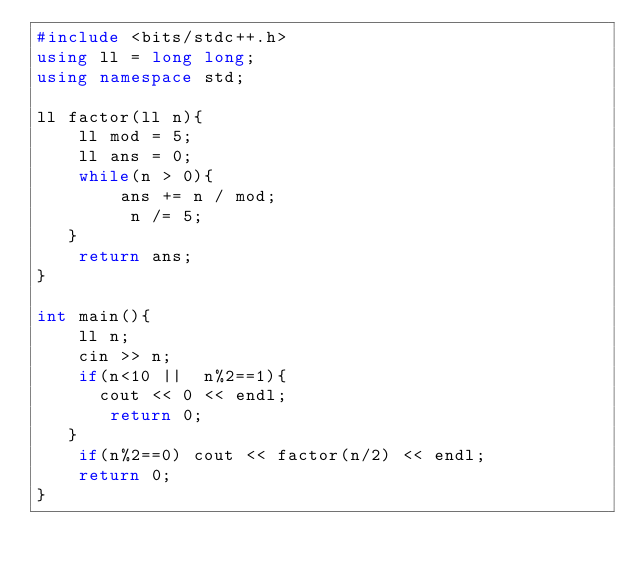Convert code to text. <code><loc_0><loc_0><loc_500><loc_500><_C++_>#include <bits/stdc++.h>
using ll = long long;
using namespace std;

ll factor(ll n){
    ll mod = 5;
    ll ans = 0;
    while(n > 0){
        ans += n / mod;
         n /= 5;
   }      
    return ans;
}

int main(){
    ll n;
    cin >> n;
    if(n<10 ||  n%2==1){
      cout << 0 << endl;
       return 0;
   }
    if(n%2==0) cout << factor(n/2) << endl;
    return 0;
}</code> 